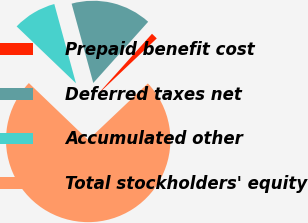Convert chart to OTSL. <chart><loc_0><loc_0><loc_500><loc_500><pie_chart><fcel>Prepaid benefit cost<fcel>Deferred taxes net<fcel>Accumulated other<fcel>Total stockholders' equity<nl><fcel>1.29%<fcel>15.88%<fcel>8.59%<fcel>74.24%<nl></chart> 